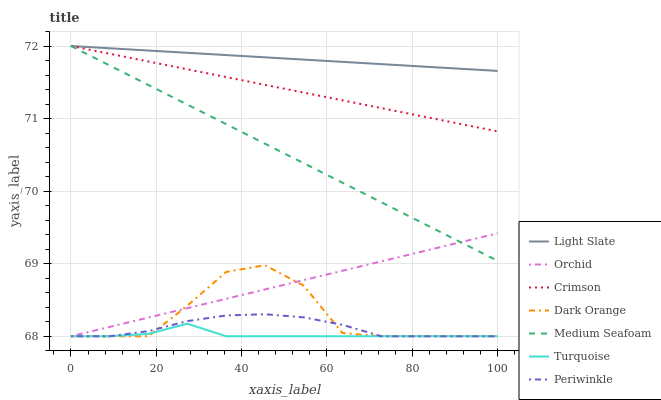Does Turquoise have the minimum area under the curve?
Answer yes or no. Yes. Does Light Slate have the maximum area under the curve?
Answer yes or no. Yes. Does Light Slate have the minimum area under the curve?
Answer yes or no. No. Does Turquoise have the maximum area under the curve?
Answer yes or no. No. Is Crimson the smoothest?
Answer yes or no. Yes. Is Dark Orange the roughest?
Answer yes or no. Yes. Is Turquoise the smoothest?
Answer yes or no. No. Is Turquoise the roughest?
Answer yes or no. No. Does Dark Orange have the lowest value?
Answer yes or no. Yes. Does Light Slate have the lowest value?
Answer yes or no. No. Does Medium Seafoam have the highest value?
Answer yes or no. Yes. Does Turquoise have the highest value?
Answer yes or no. No. Is Orchid less than Crimson?
Answer yes or no. Yes. Is Crimson greater than Periwinkle?
Answer yes or no. Yes. Does Orchid intersect Medium Seafoam?
Answer yes or no. Yes. Is Orchid less than Medium Seafoam?
Answer yes or no. No. Is Orchid greater than Medium Seafoam?
Answer yes or no. No. Does Orchid intersect Crimson?
Answer yes or no. No. 